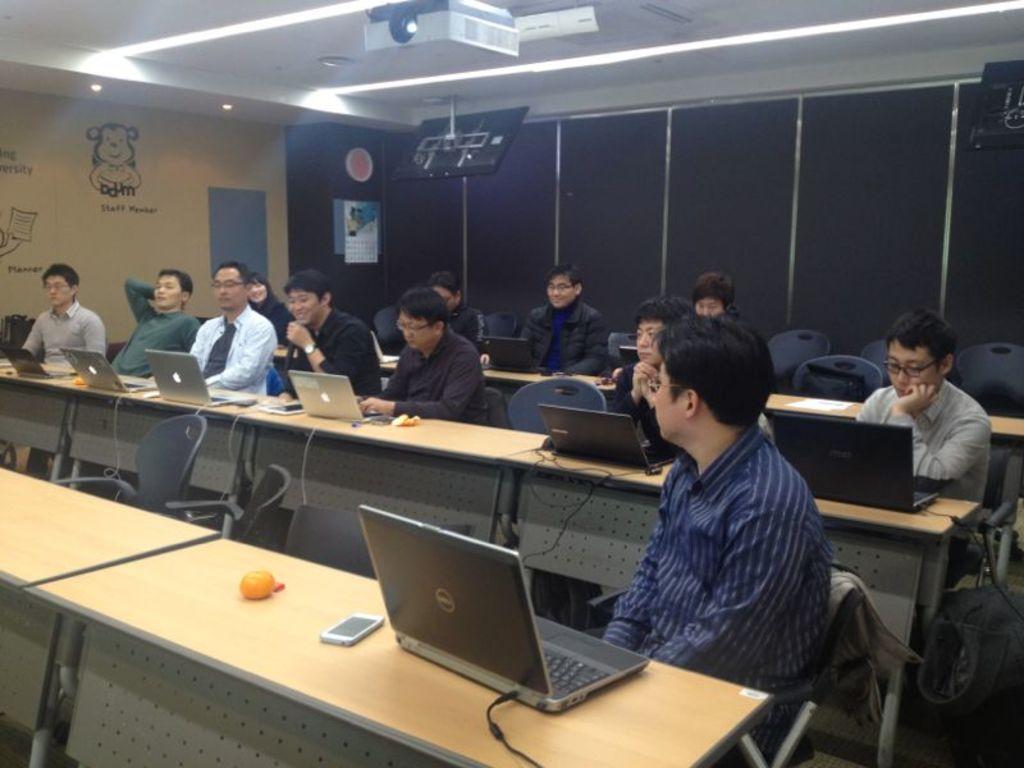How would you summarize this image in a sentence or two? In this image i can see number of people sitting on chairs in front of a desk, On the desk I can see few laptops and few wires. In the background i can see the wall, the ceiling, lights and the projector. 